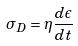Convert formula to latex. <formula><loc_0><loc_0><loc_500><loc_500>\sigma _ { D } = \eta \frac { d \epsilon } { d t }</formula> 